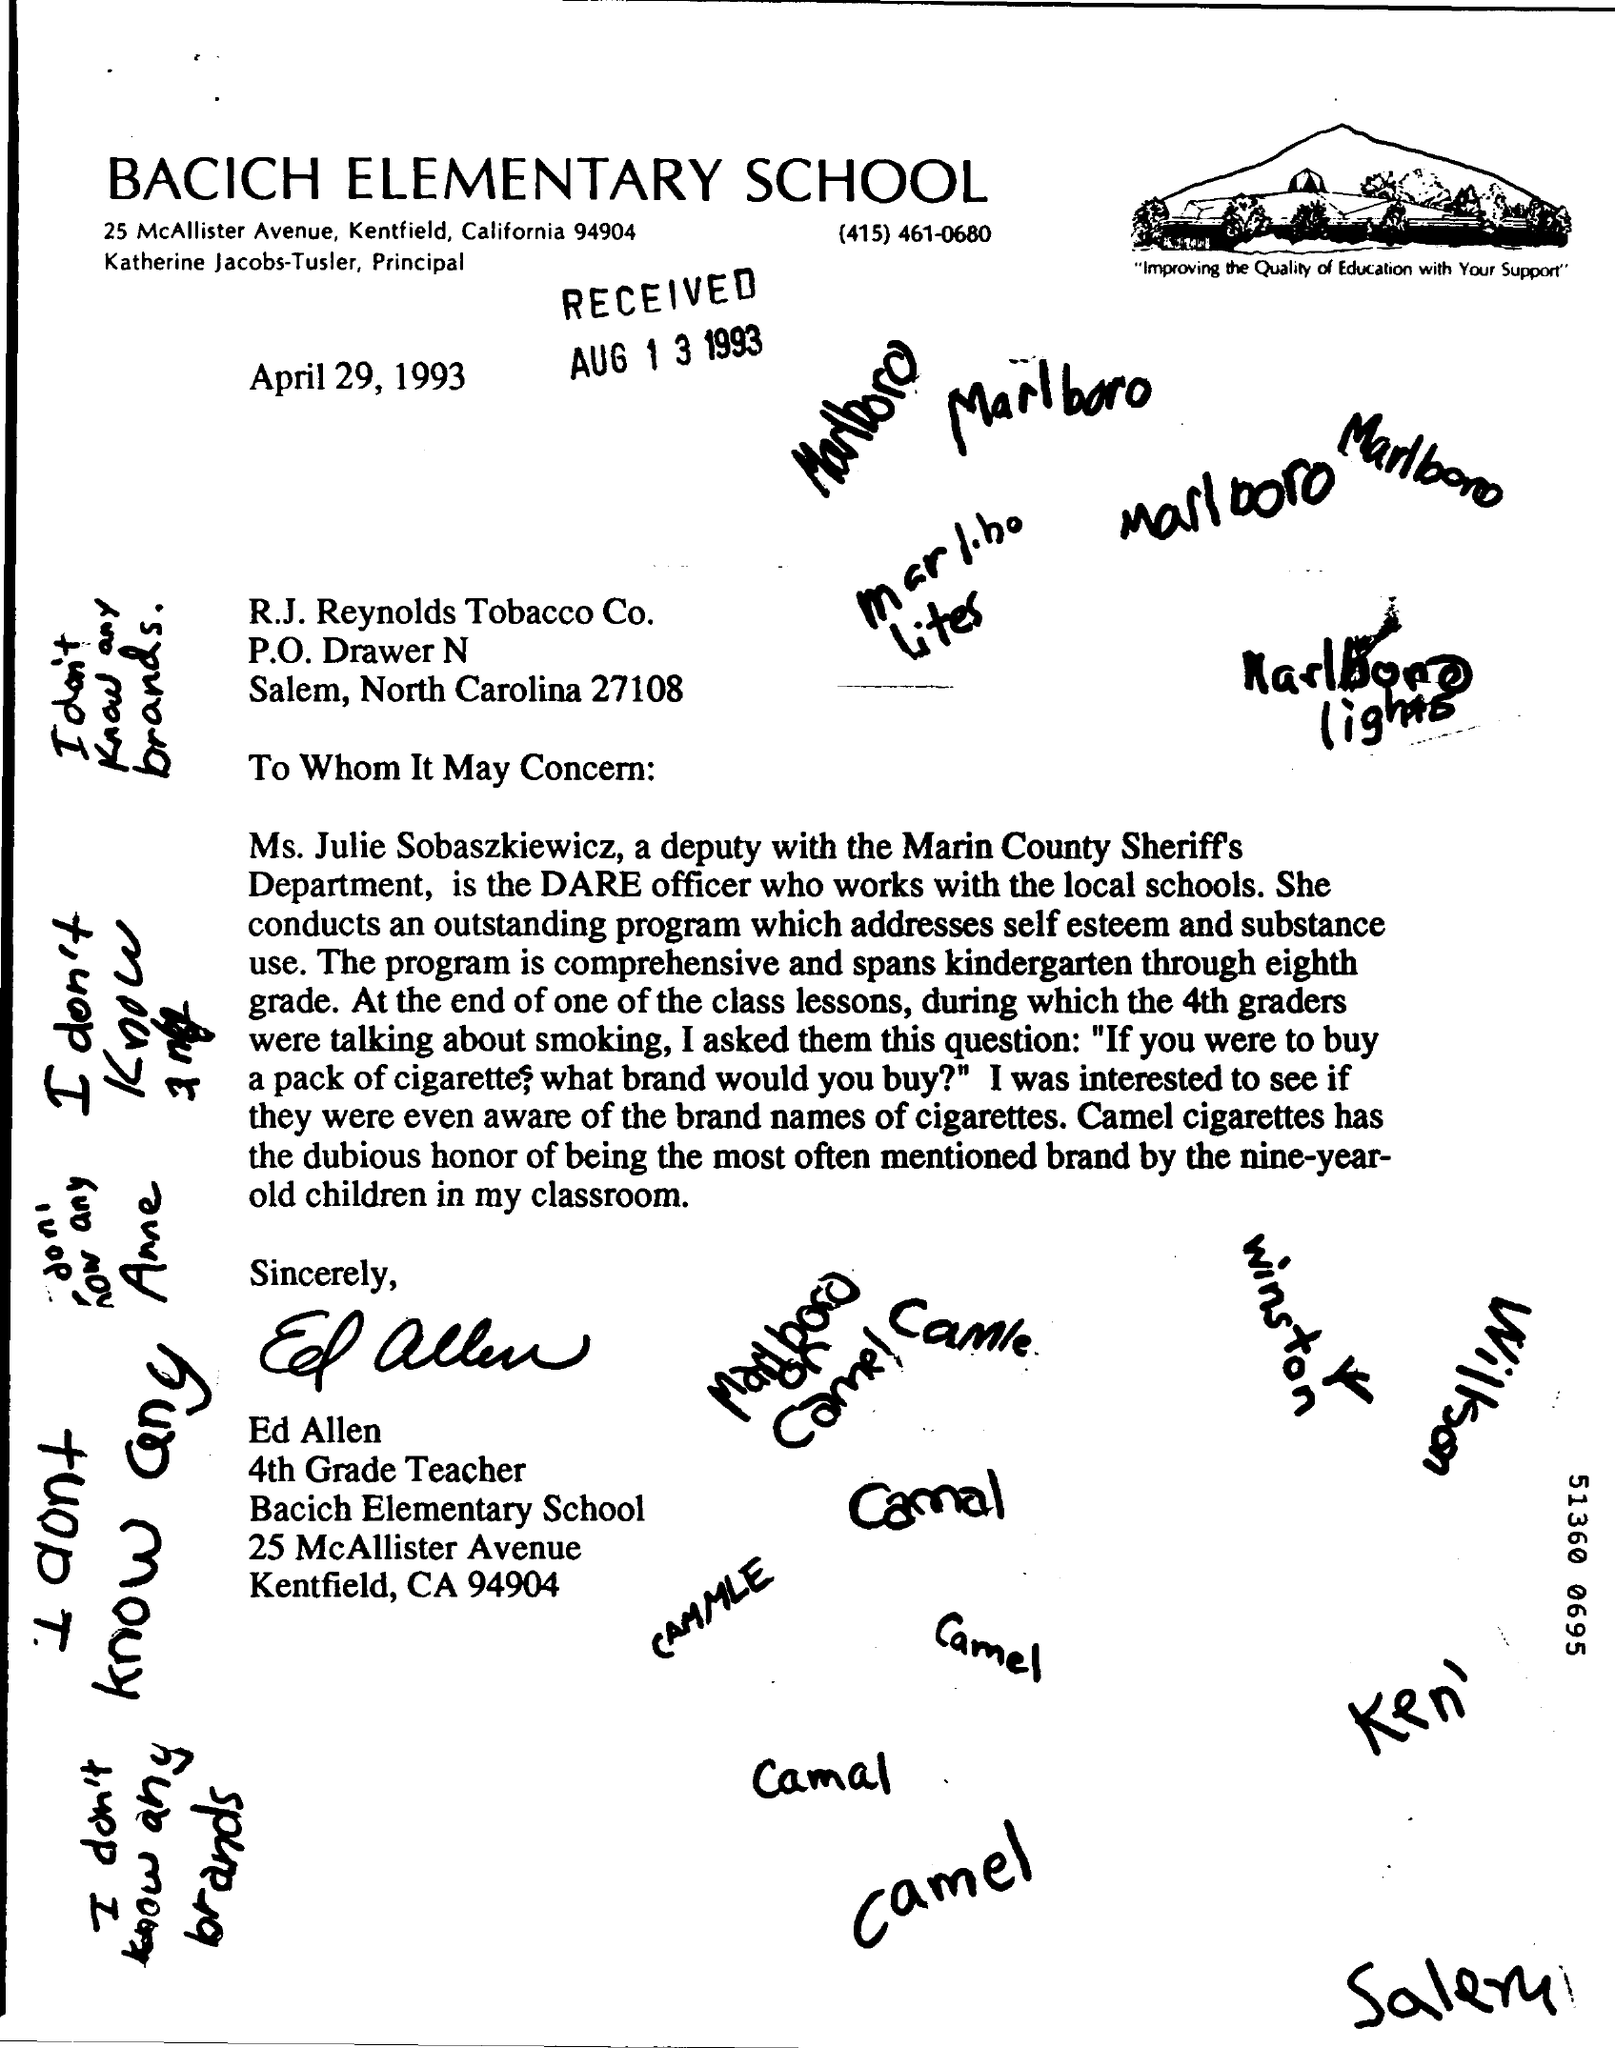Draw attention to some important aspects in this diagram. On the letter is written the date of April 29, 1993. The School Name is Bacich Elementary School. The received date is August 13, 1993. 